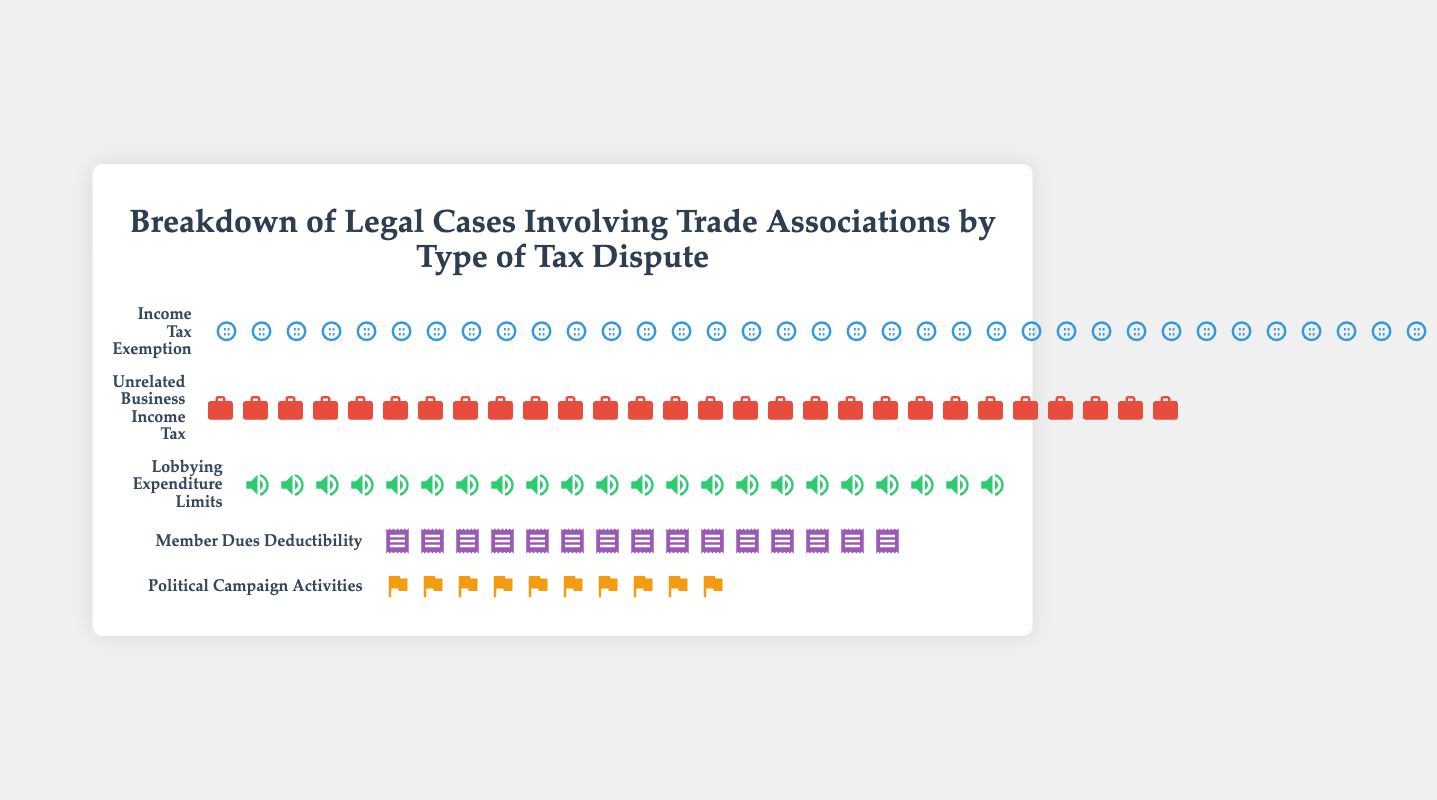What is the title of the figure? The title of the figure is displayed at the top, providing an overview of what the data represents.
Answer: Breakdown of Legal Cases Involving Trade Associations by Type of Tax Dispute How many types of tax disputes are represented in the figure? By counting the separate categories listed with their respective icons and values, we can determine the number of types of tax disputes.
Answer: Five Which category has the highest number of legal cases? By comparing the values associated with each category, the one with the highest numerical value has the most legal cases.
Answer: Income Tax Exemption How many more legal cases does "Income Tax Exemption" have compared to "Political Campaign Activities"? Subtract the value of "Political Campaign Activities" from the value of "Income Tax Exemption" to find the difference.
Answer: 25 What is the total number of legal cases represented in the figure? Add up the values from each category: 35 (Income Tax Exemption) + 28 (Unrelated Business Income Tax) + 22 (Lobbying Expenditure Limits) + 15 (Member Dues Deductibility) + 10 (Political Campaign Activities).
Answer: 110 Which category has the least number of legal cases? By comparing the values of all categories, the one with the smallest number is identified.
Answer: Political Campaign Activities How many cases are represented by "Unrelated Business Income Tax" and "Lobbying Expenditure Limits" combined? Add the values from the two categories: 28 (Unrelated Business Income Tax) + 22 (Lobbying Expenditure Limits).
Answer: 50 What percentage of the total cases does the "Member Dues Deductibility" category represent? Divide the number of cases for "Member Dues Deductibility" by the total number of cases, then multiply by 100 to get the percentage. So, 15/110 * 100.
Answer: 13.64% In which category would a legal case involving tax disputes over political activities fall under? The visual representation uses specific icons to differentiate categories, and the one involving political activities uses a flag icon, label as "Political Campaign Activities."
Answer: Political Campaign Activities Are there more legal cases involving "Lobbying Expenditure Limits" or "Unrelated Business Income Tax"? By comparing the values, 22 for "Lobbying Expenditure Limits" and 28 for "Unrelated Business Income Tax," it can be determined which is greater.
Answer: Unrelated Business Income Tax 